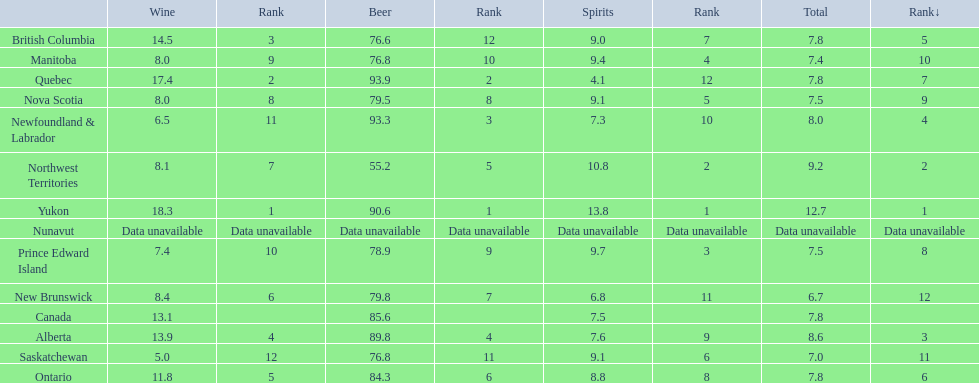Which locations consume the same total amount of alcoholic beverages as another location? British Columbia, Ontario, Quebec, Prince Edward Island, Nova Scotia. Which of these consumes more then 80 of beer? Ontario, Quebec. Of those what was the consumption of spirits of the one that consumed the most beer? 4.1. 